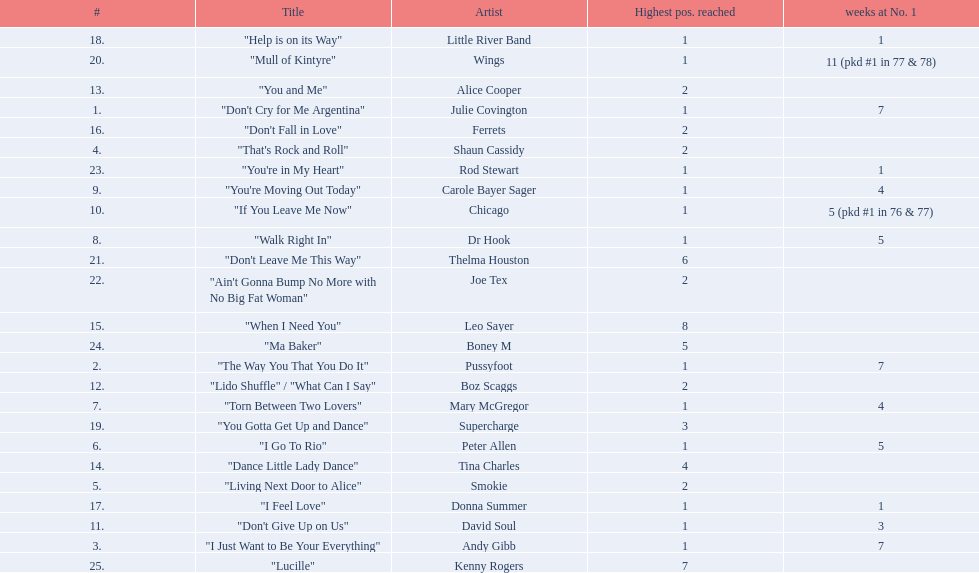Who had the one of the least weeks at number one? Rod Stewart. Who had no week at number one? Shaun Cassidy. Who had the highest number of weeks at number one? Wings. 